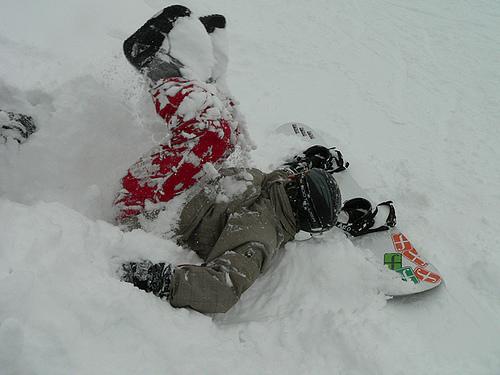What kind of board is that?
Answer briefly. Snowboard. Is the person making a snow angel?
Give a very brief answer. No. What just happened to this person?
Write a very short answer. Fell down. 